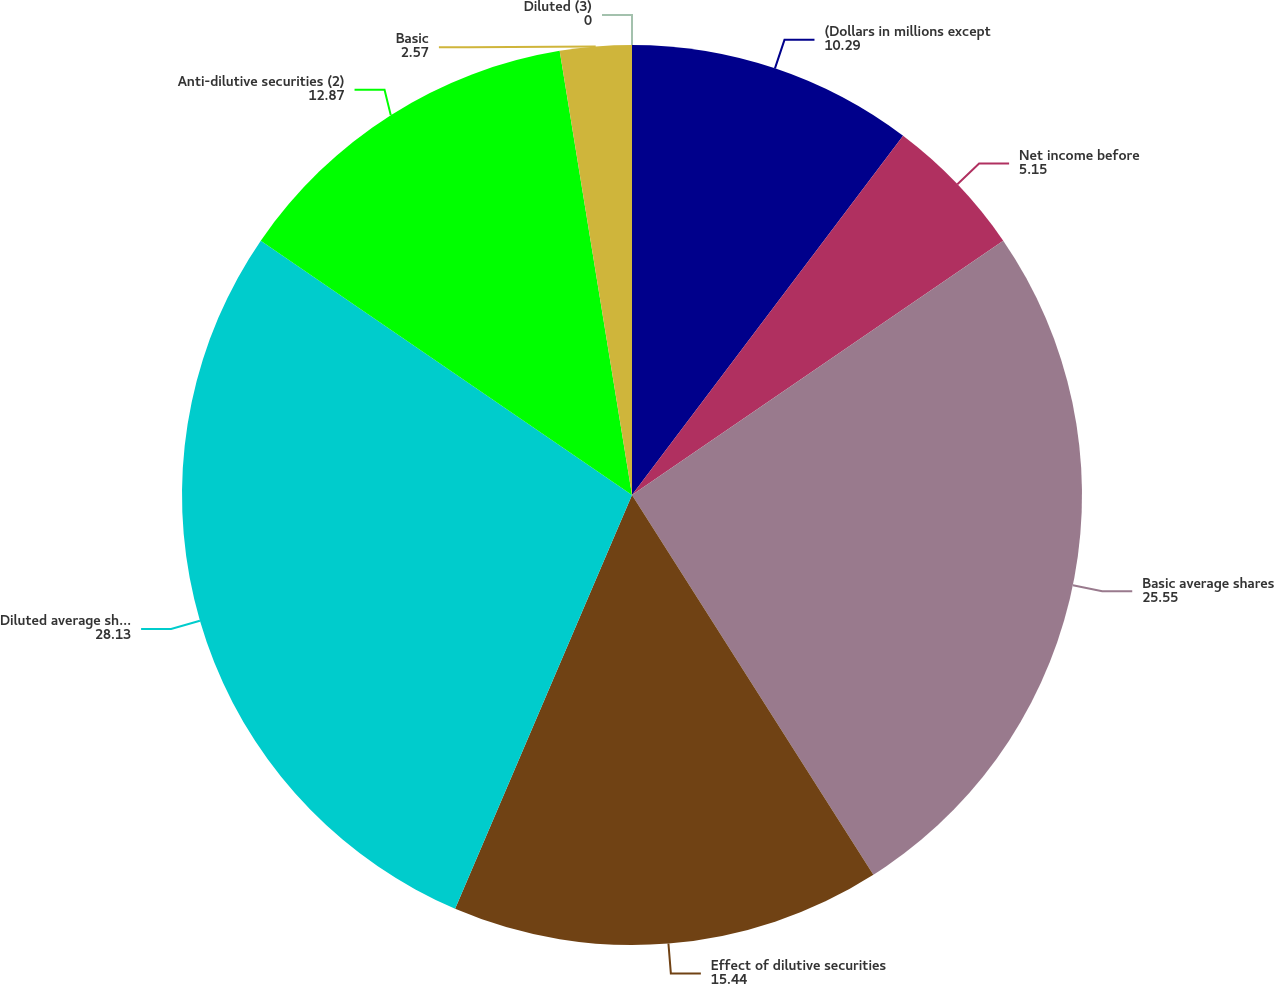Convert chart to OTSL. <chart><loc_0><loc_0><loc_500><loc_500><pie_chart><fcel>(Dollars in millions except<fcel>Net income before<fcel>Basic average shares<fcel>Effect of dilutive securities<fcel>Diluted average shares<fcel>Anti-dilutive securities (2)<fcel>Basic<fcel>Diluted (3)<nl><fcel>10.29%<fcel>5.15%<fcel>25.55%<fcel>15.44%<fcel>28.13%<fcel>12.87%<fcel>2.57%<fcel>0.0%<nl></chart> 